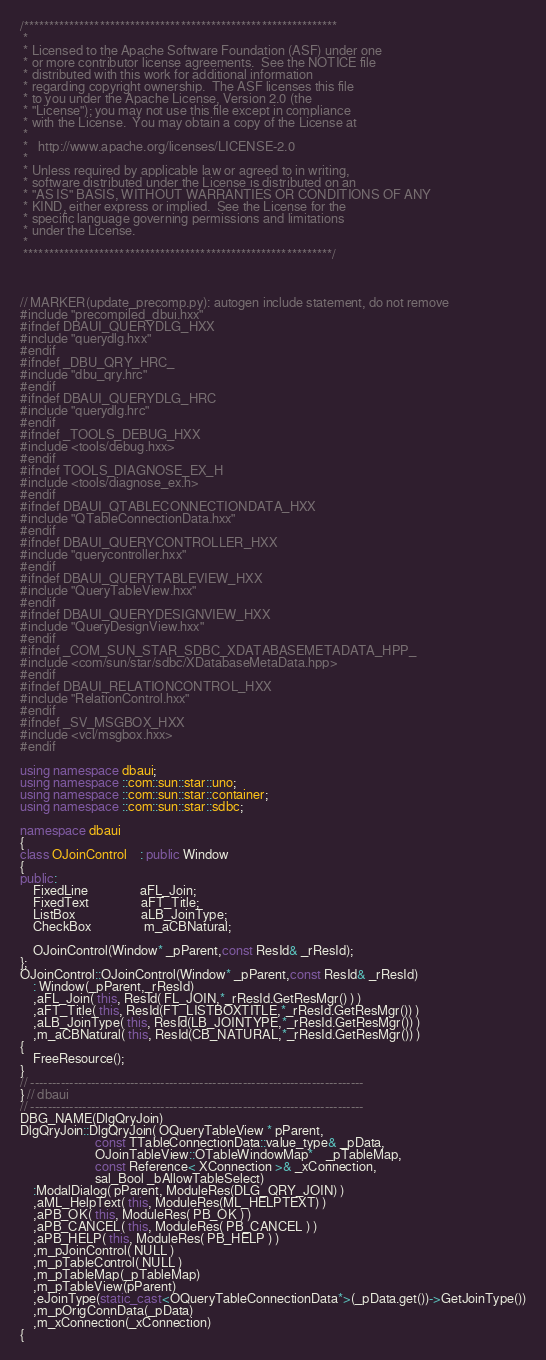<code> <loc_0><loc_0><loc_500><loc_500><_C++_>/**************************************************************
 * 
 * Licensed to the Apache Software Foundation (ASF) under one
 * or more contributor license agreements.  See the NOTICE file
 * distributed with this work for additional information
 * regarding copyright ownership.  The ASF licenses this file
 * to you under the Apache License, Version 2.0 (the
 * "License"); you may not use this file except in compliance
 * with the License.  You may obtain a copy of the License at
 * 
 *   http://www.apache.org/licenses/LICENSE-2.0
 * 
 * Unless required by applicable law or agreed to in writing,
 * software distributed under the License is distributed on an
 * "AS IS" BASIS, WITHOUT WARRANTIES OR CONDITIONS OF ANY
 * KIND, either express or implied.  See the License for the
 * specific language governing permissions and limitations
 * under the License.
 * 
 *************************************************************/



// MARKER(update_precomp.py): autogen include statement, do not remove
#include "precompiled_dbui.hxx"
#ifndef DBAUI_QUERYDLG_HXX
#include "querydlg.hxx"
#endif
#ifndef _DBU_QRY_HRC_
#include "dbu_qry.hrc"
#endif
#ifndef DBAUI_QUERYDLG_HRC
#include "querydlg.hrc"
#endif
#ifndef _TOOLS_DEBUG_HXX
#include <tools/debug.hxx>
#endif
#ifndef TOOLS_DIAGNOSE_EX_H
#include <tools/diagnose_ex.h>
#endif
#ifndef DBAUI_QTABLECONNECTIONDATA_HXX
#include "QTableConnectionData.hxx"
#endif
#ifndef DBAUI_QUERYCONTROLLER_HXX
#include "querycontroller.hxx"
#endif
#ifndef DBAUI_QUERYTABLEVIEW_HXX
#include "QueryTableView.hxx"
#endif
#ifndef DBAUI_QUERYDESIGNVIEW_HXX
#include "QueryDesignView.hxx"
#endif
#ifndef _COM_SUN_STAR_SDBC_XDATABASEMETADATA_HPP_
#include <com/sun/star/sdbc/XDatabaseMetaData.hpp>
#endif
#ifndef DBAUI_RELATIONCONTROL_HXX
#include "RelationControl.hxx"
#endif
#ifndef _SV_MSGBOX_HXX
#include <vcl/msgbox.hxx>
#endif

using namespace dbaui;
using namespace ::com::sun::star::uno;
using namespace ::com::sun::star::container;
using namespace ::com::sun::star::sdbc;

namespace dbaui
{
class OJoinControl 	: public Window
{
public:
    FixedLine				aFL_Join;
	FixedText				aFT_Title;
	ListBox					aLB_JoinType;
    CheckBox                m_aCBNatural;

	OJoinControl(Window* _pParent,const ResId& _rResId);
};
OJoinControl::OJoinControl(Window* _pParent,const ResId& _rResId)
    : Window(_pParent,_rResId)
    ,aFL_Join( this, ResId( FL_JOIN,*_rResId.GetResMgr() ) )
    ,aFT_Title( this, ResId(FT_LISTBOXTITLE,*_rResId.GetResMgr()) )
    ,aLB_JoinType( this, ResId(LB_JOINTYPE,*_rResId.GetResMgr()) )
    ,m_aCBNatural( this, ResId(CB_NATURAL,*_rResId.GetResMgr()) )
{
    FreeResource();
}
// -----------------------------------------------------------------------------
} // dbaui
// -----------------------------------------------------------------------------
DBG_NAME(DlgQryJoin)
DlgQryJoin::DlgQryJoin( OQueryTableView * pParent,
					   const TTableConnectionData::value_type& _pData,
					   OJoinTableView::OTableWindowMap*	_pTableMap,
					   const Reference< XConnection >& _xConnection,
					   sal_Bool _bAllowTableSelect)
    :ModalDialog( pParent, ModuleRes(DLG_QRY_JOIN) )
    ,aML_HelpText( this, ModuleRes(ML_HELPTEXT) )
    ,aPB_OK( this, ModuleRes( PB_OK ) )
    ,aPB_CANCEL( this, ModuleRes( PB_CANCEL ) )
    ,aPB_HELP( this, ModuleRes( PB_HELP ) )
    ,m_pJoinControl( NULL )
    ,m_pTableControl( NULL )
    ,m_pTableMap(_pTableMap)
    ,m_pTableView(pParent)
    ,eJoinType(static_cast<OQueryTableConnectionData*>(_pData.get())->GetJoinType())
    ,m_pOrigConnData(_pData)
    ,m_xConnection(_xConnection)
{</code> 